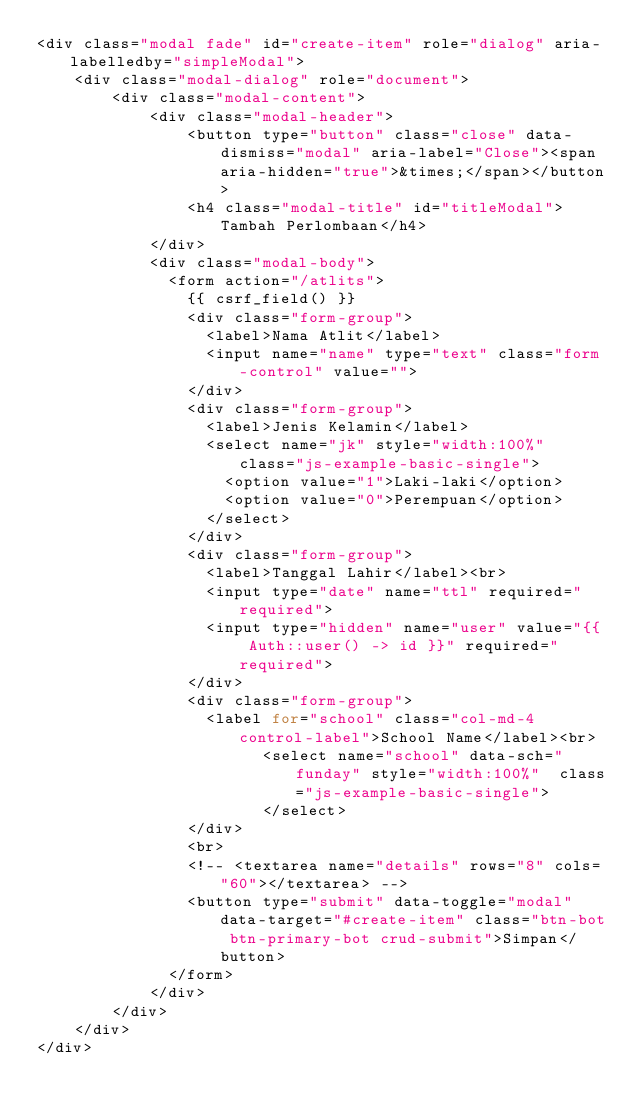Convert code to text. <code><loc_0><loc_0><loc_500><loc_500><_PHP_><div class="modal fade" id="create-item" role="dialog" aria-labelledby="simpleModal">
    <div class="modal-dialog" role="document">
        <div class="modal-content">
            <div class="modal-header">
                <button type="button" class="close" data-dismiss="modal" aria-label="Close"><span aria-hidden="true">&times;</span></button>
                <h4 class="modal-title" id="titleModal">Tambah Perlombaan</h4>
            </div>
            <div class="modal-body">
              <form action="/atlits">
                {{ csrf_field() }}
                <div class="form-group">
                  <label>Nama Atlit</label>
                  <input name="name" type="text" class="form-control" value="">
                </div>
                <div class="form-group">
                  <label>Jenis Kelamin</label>
                  <select name="jk" style="width:100%"  class="js-example-basic-single">
                    <option value="1">Laki-laki</option>
                    <option value="0">Perempuan</option>
                  </select>
                </div>
                <div class="form-group">
                  <label>Tanggal Lahir</label><br>
                  <input type="date" name="ttl" required="required">
                  <input type="hidden" name="user" value="{{ Auth::user() -> id }}" required="required">
                </div>
                <div class="form-group">
                  <label for="school" class="col-md-4 control-label">School Name</label><br>
                        <select name="school" data-sch="funday" style="width:100%"  class="js-example-basic-single">
                        </select>
                </div>
                <br>
                <!-- <textarea name="details" rows="8" cols="60"></textarea> -->
                <button type="submit" data-toggle="modal" data-target="#create-item" class="btn-bot btn-primary-bot crud-submit">Simpan</button>
              </form>
            </div>
        </div>
    </div>
</div>
</code> 